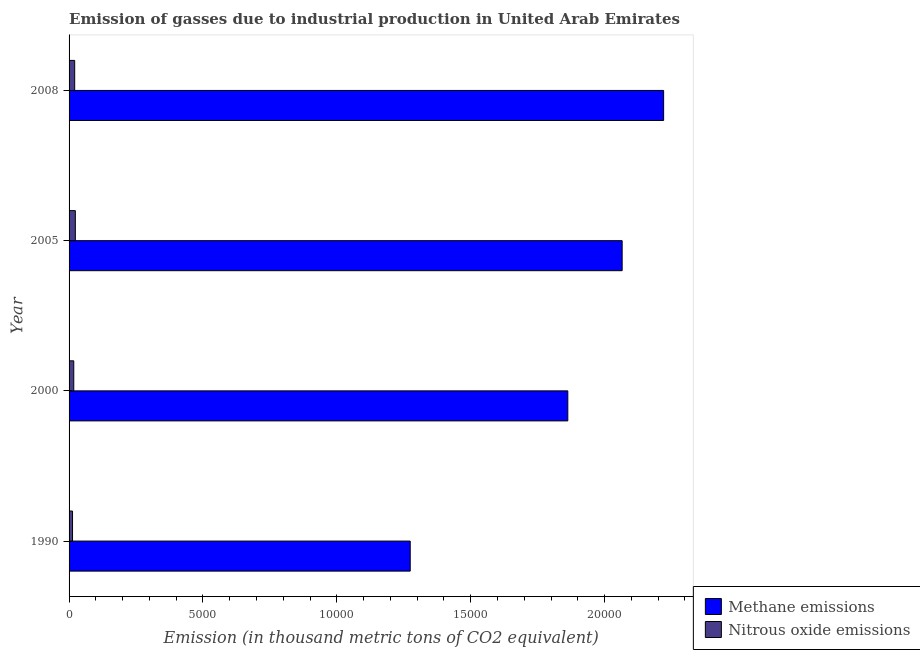How many groups of bars are there?
Ensure brevity in your answer.  4. Are the number of bars on each tick of the Y-axis equal?
Your answer should be very brief. Yes. How many bars are there on the 4th tick from the bottom?
Provide a succinct answer. 2. In how many cases, is the number of bars for a given year not equal to the number of legend labels?
Your answer should be compact. 0. What is the amount of nitrous oxide emissions in 2008?
Make the answer very short. 209.7. Across all years, what is the maximum amount of nitrous oxide emissions?
Provide a succinct answer. 234. Across all years, what is the minimum amount of methane emissions?
Offer a terse response. 1.27e+04. In which year was the amount of methane emissions maximum?
Your answer should be compact. 2008. What is the total amount of methane emissions in the graph?
Make the answer very short. 7.42e+04. What is the difference between the amount of methane emissions in 1990 and that in 2005?
Provide a short and direct response. -7915.3. What is the difference between the amount of methane emissions in 2008 and the amount of nitrous oxide emissions in 1990?
Your answer should be very brief. 2.21e+04. What is the average amount of methane emissions per year?
Make the answer very short. 1.86e+04. In the year 2000, what is the difference between the amount of methane emissions and amount of nitrous oxide emissions?
Give a very brief answer. 1.85e+04. In how many years, is the amount of methane emissions greater than 7000 thousand metric tons?
Ensure brevity in your answer.  4. What is the ratio of the amount of methane emissions in 2000 to that in 2005?
Your response must be concise. 0.9. Is the amount of nitrous oxide emissions in 2000 less than that in 2005?
Provide a succinct answer. Yes. Is the difference between the amount of nitrous oxide emissions in 1990 and 2008 greater than the difference between the amount of methane emissions in 1990 and 2008?
Make the answer very short. Yes. What is the difference between the highest and the second highest amount of methane emissions?
Ensure brevity in your answer.  1549. What is the difference between the highest and the lowest amount of nitrous oxide emissions?
Offer a very short reply. 104.8. In how many years, is the amount of methane emissions greater than the average amount of methane emissions taken over all years?
Ensure brevity in your answer.  3. What does the 2nd bar from the top in 2005 represents?
Ensure brevity in your answer.  Methane emissions. What does the 1st bar from the bottom in 2005 represents?
Provide a short and direct response. Methane emissions. How many bars are there?
Offer a very short reply. 8. Are all the bars in the graph horizontal?
Offer a very short reply. Yes. How many years are there in the graph?
Your response must be concise. 4. What is the difference between two consecutive major ticks on the X-axis?
Your response must be concise. 5000. Does the graph contain grids?
Offer a very short reply. No. How many legend labels are there?
Offer a terse response. 2. How are the legend labels stacked?
Your answer should be very brief. Vertical. What is the title of the graph?
Offer a terse response. Emission of gasses due to industrial production in United Arab Emirates. Does "Rural Population" appear as one of the legend labels in the graph?
Your answer should be compact. No. What is the label or title of the X-axis?
Keep it short and to the point. Emission (in thousand metric tons of CO2 equivalent). What is the label or title of the Y-axis?
Ensure brevity in your answer.  Year. What is the Emission (in thousand metric tons of CO2 equivalent) in Methane emissions in 1990?
Provide a succinct answer. 1.27e+04. What is the Emission (in thousand metric tons of CO2 equivalent) of Nitrous oxide emissions in 1990?
Offer a terse response. 129.2. What is the Emission (in thousand metric tons of CO2 equivalent) of Methane emissions in 2000?
Provide a short and direct response. 1.86e+04. What is the Emission (in thousand metric tons of CO2 equivalent) in Nitrous oxide emissions in 2000?
Ensure brevity in your answer.  175.5. What is the Emission (in thousand metric tons of CO2 equivalent) of Methane emissions in 2005?
Your answer should be compact. 2.07e+04. What is the Emission (in thousand metric tons of CO2 equivalent) in Nitrous oxide emissions in 2005?
Provide a succinct answer. 234. What is the Emission (in thousand metric tons of CO2 equivalent) in Methane emissions in 2008?
Give a very brief answer. 2.22e+04. What is the Emission (in thousand metric tons of CO2 equivalent) in Nitrous oxide emissions in 2008?
Your response must be concise. 209.7. Across all years, what is the maximum Emission (in thousand metric tons of CO2 equivalent) in Methane emissions?
Provide a short and direct response. 2.22e+04. Across all years, what is the maximum Emission (in thousand metric tons of CO2 equivalent) in Nitrous oxide emissions?
Make the answer very short. 234. Across all years, what is the minimum Emission (in thousand metric tons of CO2 equivalent) in Methane emissions?
Your answer should be compact. 1.27e+04. Across all years, what is the minimum Emission (in thousand metric tons of CO2 equivalent) of Nitrous oxide emissions?
Provide a short and direct response. 129.2. What is the total Emission (in thousand metric tons of CO2 equivalent) in Methane emissions in the graph?
Ensure brevity in your answer.  7.42e+04. What is the total Emission (in thousand metric tons of CO2 equivalent) in Nitrous oxide emissions in the graph?
Keep it short and to the point. 748.4. What is the difference between the Emission (in thousand metric tons of CO2 equivalent) in Methane emissions in 1990 and that in 2000?
Your answer should be very brief. -5885.7. What is the difference between the Emission (in thousand metric tons of CO2 equivalent) in Nitrous oxide emissions in 1990 and that in 2000?
Keep it short and to the point. -46.3. What is the difference between the Emission (in thousand metric tons of CO2 equivalent) of Methane emissions in 1990 and that in 2005?
Ensure brevity in your answer.  -7915.3. What is the difference between the Emission (in thousand metric tons of CO2 equivalent) of Nitrous oxide emissions in 1990 and that in 2005?
Give a very brief answer. -104.8. What is the difference between the Emission (in thousand metric tons of CO2 equivalent) of Methane emissions in 1990 and that in 2008?
Your answer should be compact. -9464.3. What is the difference between the Emission (in thousand metric tons of CO2 equivalent) in Nitrous oxide emissions in 1990 and that in 2008?
Offer a terse response. -80.5. What is the difference between the Emission (in thousand metric tons of CO2 equivalent) of Methane emissions in 2000 and that in 2005?
Provide a succinct answer. -2029.6. What is the difference between the Emission (in thousand metric tons of CO2 equivalent) in Nitrous oxide emissions in 2000 and that in 2005?
Offer a terse response. -58.5. What is the difference between the Emission (in thousand metric tons of CO2 equivalent) of Methane emissions in 2000 and that in 2008?
Provide a short and direct response. -3578.6. What is the difference between the Emission (in thousand metric tons of CO2 equivalent) in Nitrous oxide emissions in 2000 and that in 2008?
Your answer should be compact. -34.2. What is the difference between the Emission (in thousand metric tons of CO2 equivalent) of Methane emissions in 2005 and that in 2008?
Your answer should be very brief. -1549. What is the difference between the Emission (in thousand metric tons of CO2 equivalent) in Nitrous oxide emissions in 2005 and that in 2008?
Provide a succinct answer. 24.3. What is the difference between the Emission (in thousand metric tons of CO2 equivalent) in Methane emissions in 1990 and the Emission (in thousand metric tons of CO2 equivalent) in Nitrous oxide emissions in 2000?
Provide a succinct answer. 1.26e+04. What is the difference between the Emission (in thousand metric tons of CO2 equivalent) of Methane emissions in 1990 and the Emission (in thousand metric tons of CO2 equivalent) of Nitrous oxide emissions in 2005?
Your answer should be very brief. 1.25e+04. What is the difference between the Emission (in thousand metric tons of CO2 equivalent) of Methane emissions in 1990 and the Emission (in thousand metric tons of CO2 equivalent) of Nitrous oxide emissions in 2008?
Provide a succinct answer. 1.25e+04. What is the difference between the Emission (in thousand metric tons of CO2 equivalent) in Methane emissions in 2000 and the Emission (in thousand metric tons of CO2 equivalent) in Nitrous oxide emissions in 2005?
Your answer should be compact. 1.84e+04. What is the difference between the Emission (in thousand metric tons of CO2 equivalent) of Methane emissions in 2000 and the Emission (in thousand metric tons of CO2 equivalent) of Nitrous oxide emissions in 2008?
Provide a succinct answer. 1.84e+04. What is the difference between the Emission (in thousand metric tons of CO2 equivalent) in Methane emissions in 2005 and the Emission (in thousand metric tons of CO2 equivalent) in Nitrous oxide emissions in 2008?
Provide a succinct answer. 2.04e+04. What is the average Emission (in thousand metric tons of CO2 equivalent) in Methane emissions per year?
Make the answer very short. 1.86e+04. What is the average Emission (in thousand metric tons of CO2 equivalent) in Nitrous oxide emissions per year?
Offer a very short reply. 187.1. In the year 1990, what is the difference between the Emission (in thousand metric tons of CO2 equivalent) of Methane emissions and Emission (in thousand metric tons of CO2 equivalent) of Nitrous oxide emissions?
Provide a succinct answer. 1.26e+04. In the year 2000, what is the difference between the Emission (in thousand metric tons of CO2 equivalent) in Methane emissions and Emission (in thousand metric tons of CO2 equivalent) in Nitrous oxide emissions?
Give a very brief answer. 1.85e+04. In the year 2005, what is the difference between the Emission (in thousand metric tons of CO2 equivalent) of Methane emissions and Emission (in thousand metric tons of CO2 equivalent) of Nitrous oxide emissions?
Provide a succinct answer. 2.04e+04. In the year 2008, what is the difference between the Emission (in thousand metric tons of CO2 equivalent) in Methane emissions and Emission (in thousand metric tons of CO2 equivalent) in Nitrous oxide emissions?
Offer a terse response. 2.20e+04. What is the ratio of the Emission (in thousand metric tons of CO2 equivalent) in Methane emissions in 1990 to that in 2000?
Offer a terse response. 0.68. What is the ratio of the Emission (in thousand metric tons of CO2 equivalent) in Nitrous oxide emissions in 1990 to that in 2000?
Provide a short and direct response. 0.74. What is the ratio of the Emission (in thousand metric tons of CO2 equivalent) of Methane emissions in 1990 to that in 2005?
Keep it short and to the point. 0.62. What is the ratio of the Emission (in thousand metric tons of CO2 equivalent) of Nitrous oxide emissions in 1990 to that in 2005?
Ensure brevity in your answer.  0.55. What is the ratio of the Emission (in thousand metric tons of CO2 equivalent) in Methane emissions in 1990 to that in 2008?
Offer a terse response. 0.57. What is the ratio of the Emission (in thousand metric tons of CO2 equivalent) of Nitrous oxide emissions in 1990 to that in 2008?
Keep it short and to the point. 0.62. What is the ratio of the Emission (in thousand metric tons of CO2 equivalent) in Methane emissions in 2000 to that in 2005?
Provide a succinct answer. 0.9. What is the ratio of the Emission (in thousand metric tons of CO2 equivalent) in Methane emissions in 2000 to that in 2008?
Offer a terse response. 0.84. What is the ratio of the Emission (in thousand metric tons of CO2 equivalent) in Nitrous oxide emissions in 2000 to that in 2008?
Give a very brief answer. 0.84. What is the ratio of the Emission (in thousand metric tons of CO2 equivalent) of Methane emissions in 2005 to that in 2008?
Keep it short and to the point. 0.93. What is the ratio of the Emission (in thousand metric tons of CO2 equivalent) of Nitrous oxide emissions in 2005 to that in 2008?
Provide a succinct answer. 1.12. What is the difference between the highest and the second highest Emission (in thousand metric tons of CO2 equivalent) of Methane emissions?
Provide a short and direct response. 1549. What is the difference between the highest and the second highest Emission (in thousand metric tons of CO2 equivalent) of Nitrous oxide emissions?
Offer a terse response. 24.3. What is the difference between the highest and the lowest Emission (in thousand metric tons of CO2 equivalent) of Methane emissions?
Your response must be concise. 9464.3. What is the difference between the highest and the lowest Emission (in thousand metric tons of CO2 equivalent) in Nitrous oxide emissions?
Offer a very short reply. 104.8. 